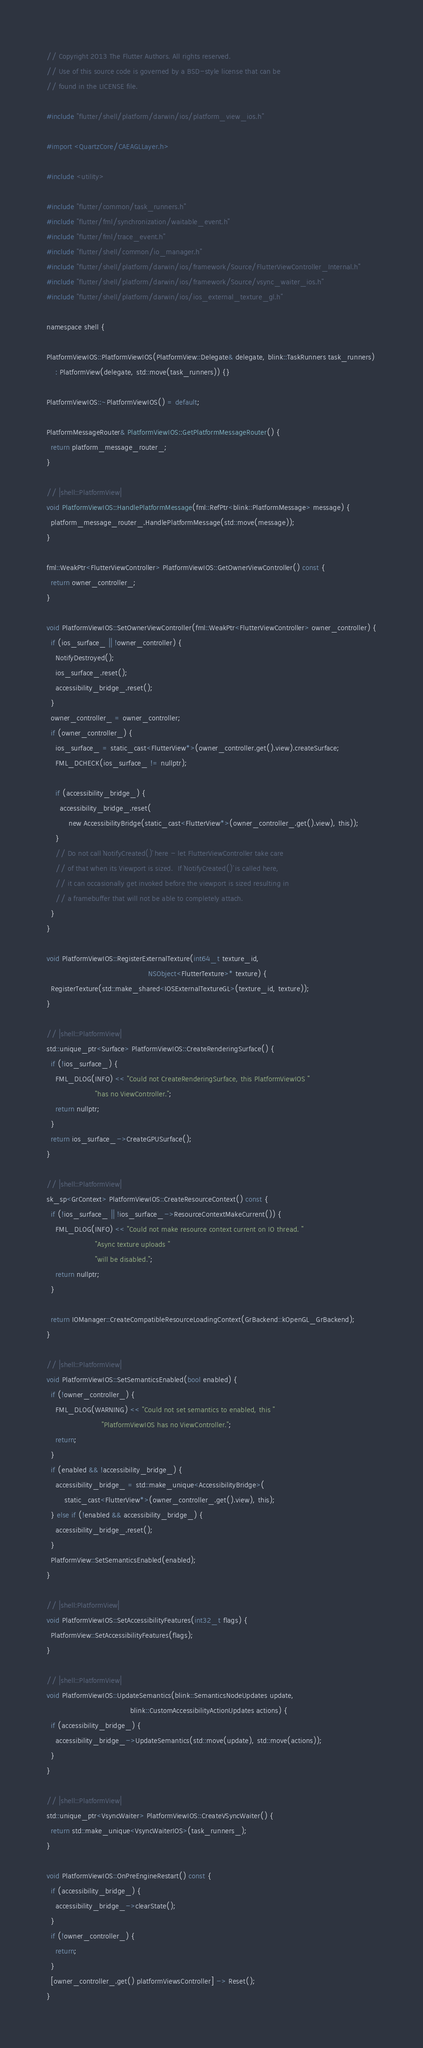<code> <loc_0><loc_0><loc_500><loc_500><_ObjectiveC_>// Copyright 2013 The Flutter Authors. All rights reserved.
// Use of this source code is governed by a BSD-style license that can be
// found in the LICENSE file.

#include "flutter/shell/platform/darwin/ios/platform_view_ios.h"

#import <QuartzCore/CAEAGLLayer.h>

#include <utility>

#include "flutter/common/task_runners.h"
#include "flutter/fml/synchronization/waitable_event.h"
#include "flutter/fml/trace_event.h"
#include "flutter/shell/common/io_manager.h"
#include "flutter/shell/platform/darwin/ios/framework/Source/FlutterViewController_Internal.h"
#include "flutter/shell/platform/darwin/ios/framework/Source/vsync_waiter_ios.h"
#include "flutter/shell/platform/darwin/ios/ios_external_texture_gl.h"

namespace shell {

PlatformViewIOS::PlatformViewIOS(PlatformView::Delegate& delegate, blink::TaskRunners task_runners)
    : PlatformView(delegate, std::move(task_runners)) {}

PlatformViewIOS::~PlatformViewIOS() = default;

PlatformMessageRouter& PlatformViewIOS::GetPlatformMessageRouter() {
  return platform_message_router_;
}

// |shell::PlatformView|
void PlatformViewIOS::HandlePlatformMessage(fml::RefPtr<blink::PlatformMessage> message) {
  platform_message_router_.HandlePlatformMessage(std::move(message));
}

fml::WeakPtr<FlutterViewController> PlatformViewIOS::GetOwnerViewController() const {
  return owner_controller_;
}

void PlatformViewIOS::SetOwnerViewController(fml::WeakPtr<FlutterViewController> owner_controller) {
  if (ios_surface_ || !owner_controller) {
    NotifyDestroyed();
    ios_surface_.reset();
    accessibility_bridge_.reset();
  }
  owner_controller_ = owner_controller;
  if (owner_controller_) {
    ios_surface_ = static_cast<FlutterView*>(owner_controller.get().view).createSurface;
    FML_DCHECK(ios_surface_ != nullptr);

    if (accessibility_bridge_) {
      accessibility_bridge_.reset(
          new AccessibilityBridge(static_cast<FlutterView*>(owner_controller_.get().view), this));
    }
    // Do not call `NotifyCreated()` here - let FlutterViewController take care
    // of that when its Viewport is sized.  If `NotifyCreated()` is called here,
    // it can occasionally get invoked before the viewport is sized resulting in
    // a framebuffer that will not be able to completely attach.
  }
}

void PlatformViewIOS::RegisterExternalTexture(int64_t texture_id,
                                              NSObject<FlutterTexture>* texture) {
  RegisterTexture(std::make_shared<IOSExternalTextureGL>(texture_id, texture));
}

// |shell::PlatformView|
std::unique_ptr<Surface> PlatformViewIOS::CreateRenderingSurface() {
  if (!ios_surface_) {
    FML_DLOG(INFO) << "Could not CreateRenderingSurface, this PlatformViewIOS "
                      "has no ViewController.";
    return nullptr;
  }
  return ios_surface_->CreateGPUSurface();
}

// |shell::PlatformView|
sk_sp<GrContext> PlatformViewIOS::CreateResourceContext() const {
  if (!ios_surface_ || !ios_surface_->ResourceContextMakeCurrent()) {
    FML_DLOG(INFO) << "Could not make resource context current on IO thread. "
                      "Async texture uploads "
                      "will be disabled.";
    return nullptr;
  }

  return IOManager::CreateCompatibleResourceLoadingContext(GrBackend::kOpenGL_GrBackend);
}

// |shell::PlatformView|
void PlatformViewIOS::SetSemanticsEnabled(bool enabled) {
  if (!owner_controller_) {
    FML_DLOG(WARNING) << "Could not set semantics to enabled, this "
                         "PlatformViewIOS has no ViewController.";
    return;
  }
  if (enabled && !accessibility_bridge_) {
    accessibility_bridge_ = std::make_unique<AccessibilityBridge>(
        static_cast<FlutterView*>(owner_controller_.get().view), this);
  } else if (!enabled && accessibility_bridge_) {
    accessibility_bridge_.reset();
  }
  PlatformView::SetSemanticsEnabled(enabled);
}

// |shell:PlatformView|
void PlatformViewIOS::SetAccessibilityFeatures(int32_t flags) {
  PlatformView::SetAccessibilityFeatures(flags);
}

// |shell::PlatformView|
void PlatformViewIOS::UpdateSemantics(blink::SemanticsNodeUpdates update,
                                      blink::CustomAccessibilityActionUpdates actions) {
  if (accessibility_bridge_) {
    accessibility_bridge_->UpdateSemantics(std::move(update), std::move(actions));
  }
}

// |shell::PlatformView|
std::unique_ptr<VsyncWaiter> PlatformViewIOS::CreateVSyncWaiter() {
  return std::make_unique<VsyncWaiterIOS>(task_runners_);
}

void PlatformViewIOS::OnPreEngineRestart() const {
  if (accessibility_bridge_) {
    accessibility_bridge_->clearState();
  }
  if (!owner_controller_) {
    return;
  }
  [owner_controller_.get() platformViewsController] -> Reset();
}
</code> 